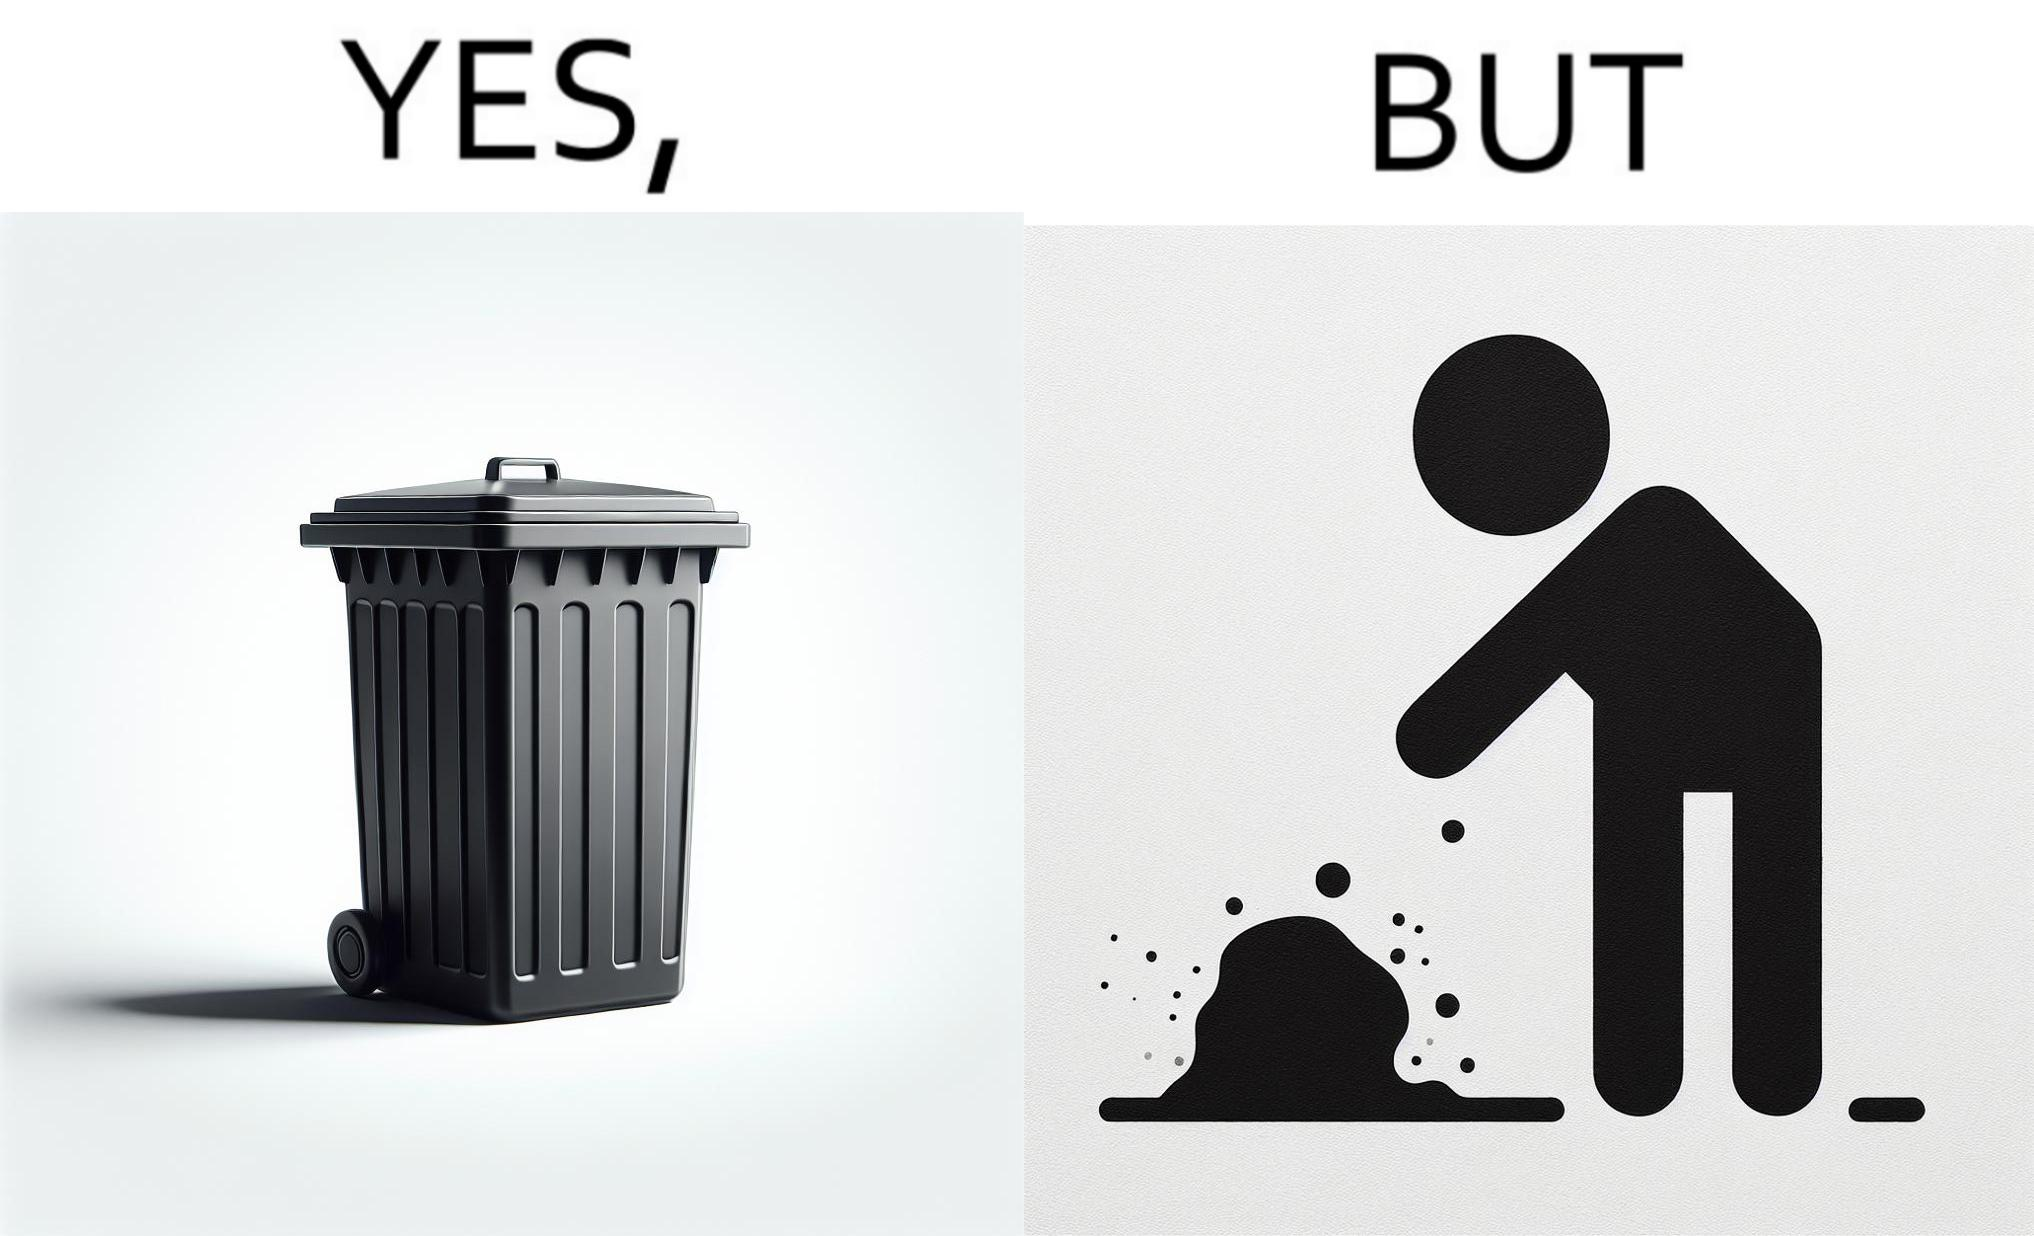Describe what you see in the left and right parts of this image. In the left part of the image: It is a garbage bin In the right part of the image: It is a human hand sticking chewing gum on public property 